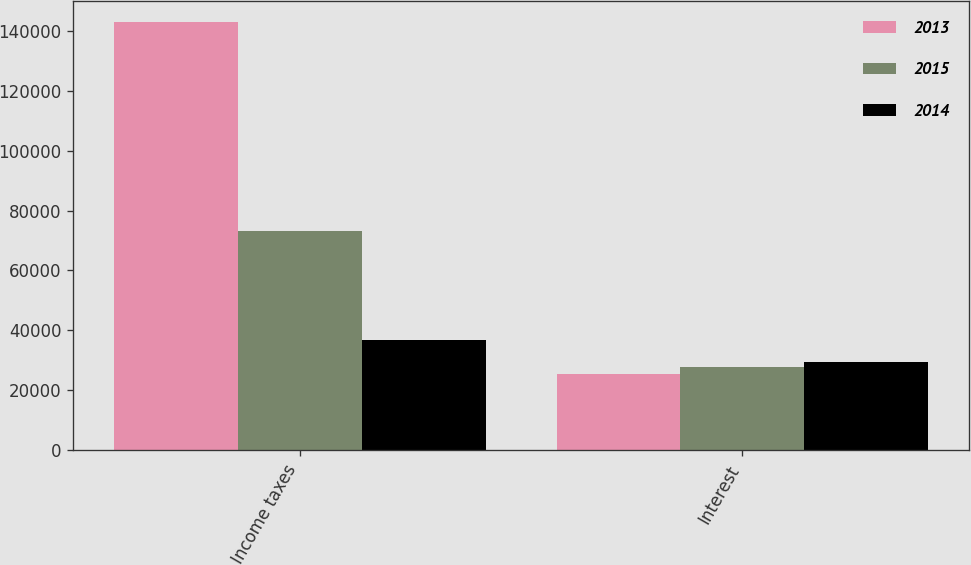Convert chart to OTSL. <chart><loc_0><loc_0><loc_500><loc_500><stacked_bar_chart><ecel><fcel>Income taxes<fcel>Interest<nl><fcel>2013<fcel>142931<fcel>25625<nl><fcel>2015<fcel>73067<fcel>27931<nl><fcel>2014<fcel>36863<fcel>29354<nl></chart> 